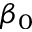Convert formula to latex. <formula><loc_0><loc_0><loc_500><loc_500>\beta _ { 0 }</formula> 